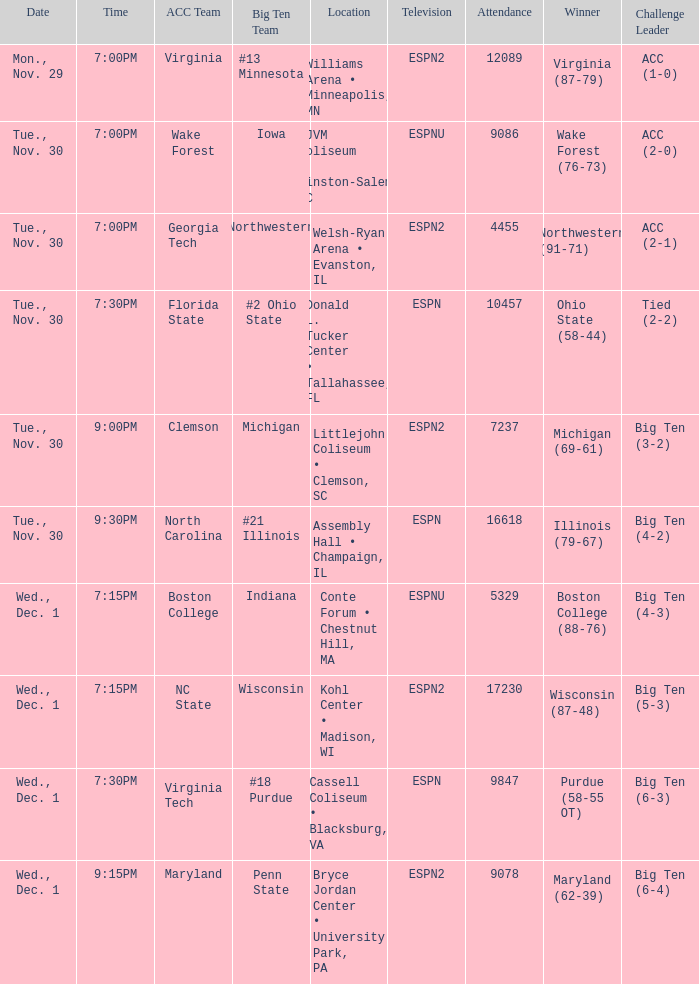Who were the challenge leaders of the games won by boston college (88-76)? Big Ten (4-3). 